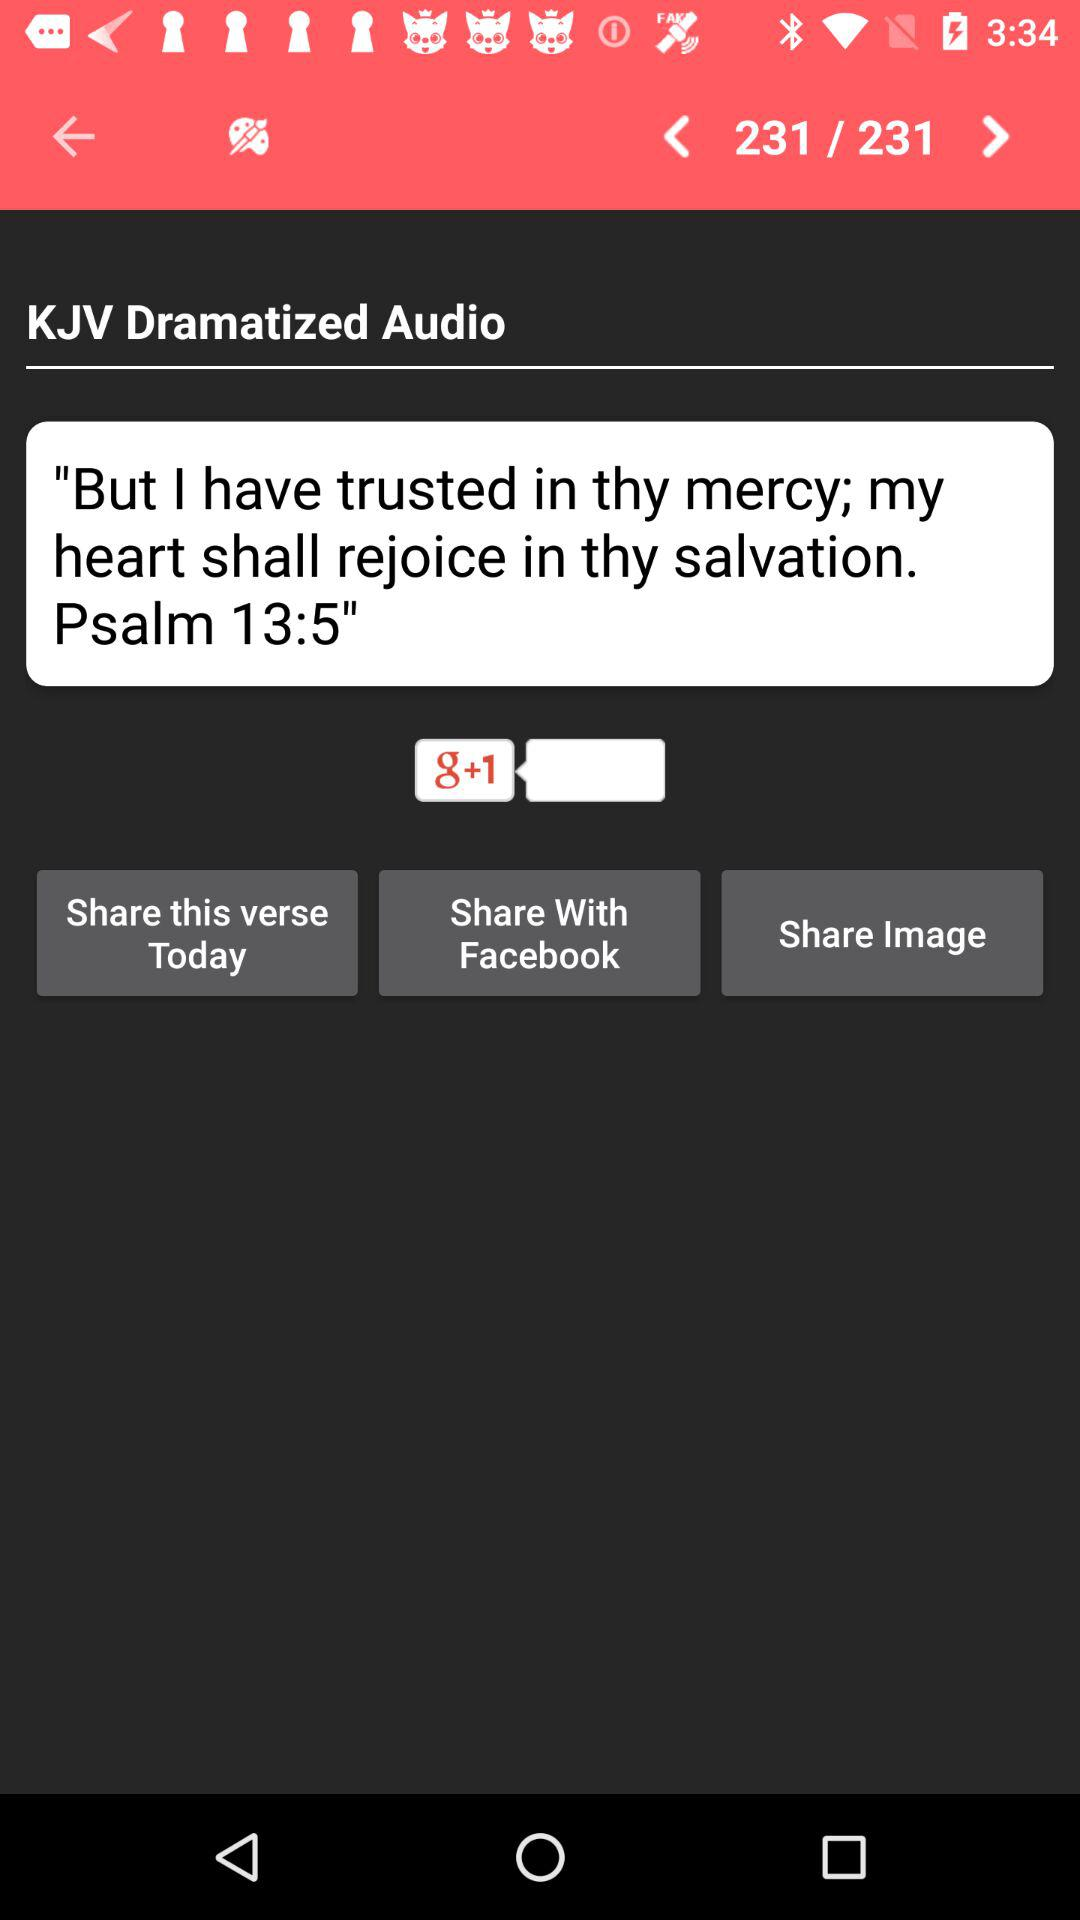What application can we use to share? You can use "Facebook" to share. 